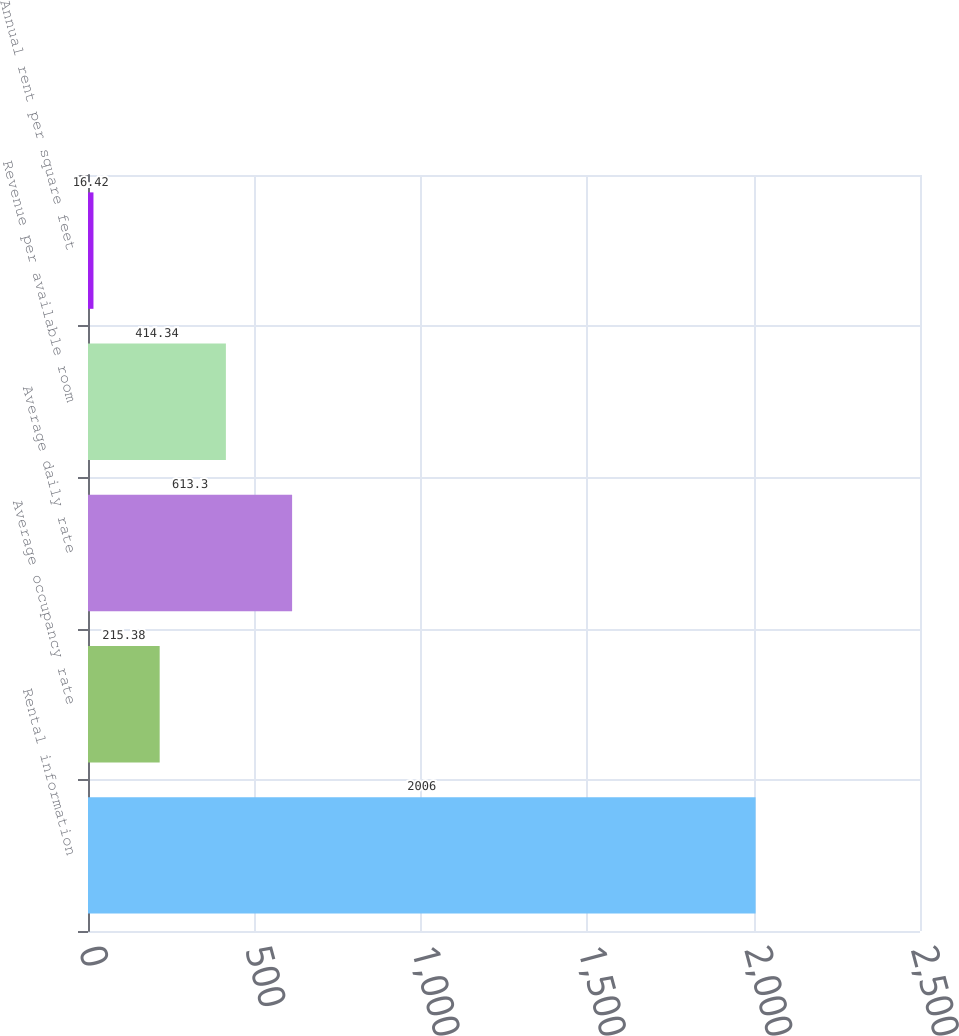Convert chart to OTSL. <chart><loc_0><loc_0><loc_500><loc_500><bar_chart><fcel>Rental information<fcel>Average occupancy rate<fcel>Average daily rate<fcel>Revenue per available room<fcel>Annual rent per square feet<nl><fcel>2006<fcel>215.38<fcel>613.3<fcel>414.34<fcel>16.42<nl></chart> 